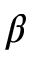<formula> <loc_0><loc_0><loc_500><loc_500>\beta</formula> 